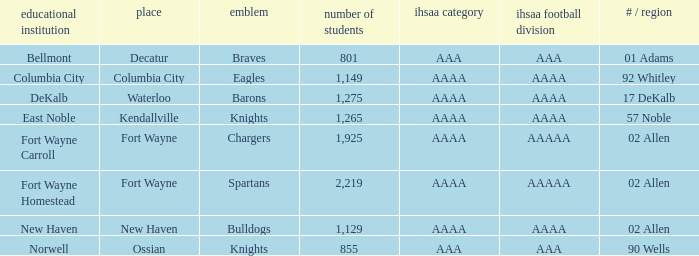What's the IHSAA Football Class in Decatur with an AAA IHSAA class? AAA. 